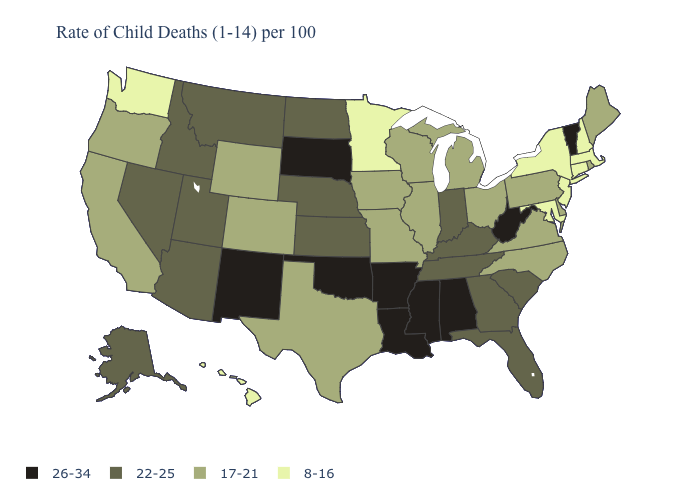Among the states that border Missouri , does Kansas have the highest value?
Quick response, please. No. Name the states that have a value in the range 8-16?
Write a very short answer. Connecticut, Hawaii, Maryland, Massachusetts, Minnesota, New Hampshire, New Jersey, New York, Washington. What is the value of Alaska?
Write a very short answer. 22-25. Does Oregon have the lowest value in the USA?
Short answer required. No. Does Delaware have the highest value in the South?
Write a very short answer. No. Which states hav the highest value in the West?
Give a very brief answer. New Mexico. Name the states that have a value in the range 26-34?
Answer briefly. Alabama, Arkansas, Louisiana, Mississippi, New Mexico, Oklahoma, South Dakota, Vermont, West Virginia. Does Georgia have the lowest value in the USA?
Write a very short answer. No. Name the states that have a value in the range 17-21?
Write a very short answer. California, Colorado, Delaware, Illinois, Iowa, Maine, Michigan, Missouri, North Carolina, Ohio, Oregon, Pennsylvania, Rhode Island, Texas, Virginia, Wisconsin, Wyoming. Name the states that have a value in the range 17-21?
Keep it brief. California, Colorado, Delaware, Illinois, Iowa, Maine, Michigan, Missouri, North Carolina, Ohio, Oregon, Pennsylvania, Rhode Island, Texas, Virginia, Wisconsin, Wyoming. Does Massachusetts have the lowest value in the USA?
Concise answer only. Yes. What is the value of Oklahoma?
Give a very brief answer. 26-34. What is the lowest value in the West?
Quick response, please. 8-16. What is the highest value in states that border Arkansas?
Concise answer only. 26-34. Name the states that have a value in the range 22-25?
Give a very brief answer. Alaska, Arizona, Florida, Georgia, Idaho, Indiana, Kansas, Kentucky, Montana, Nebraska, Nevada, North Dakota, South Carolina, Tennessee, Utah. 